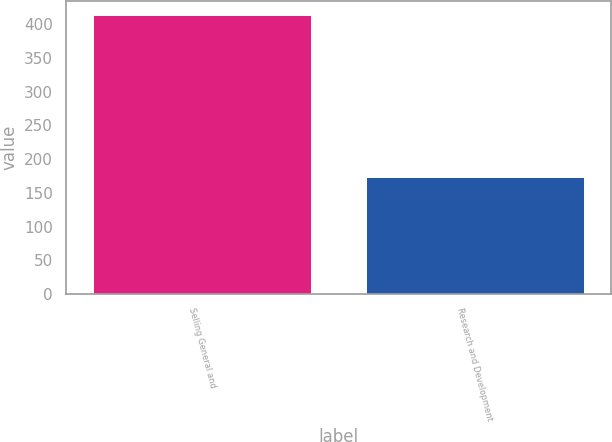<chart> <loc_0><loc_0><loc_500><loc_500><bar_chart><fcel>Selling General and<fcel>Research and Development<nl><fcel>414<fcel>173<nl></chart> 